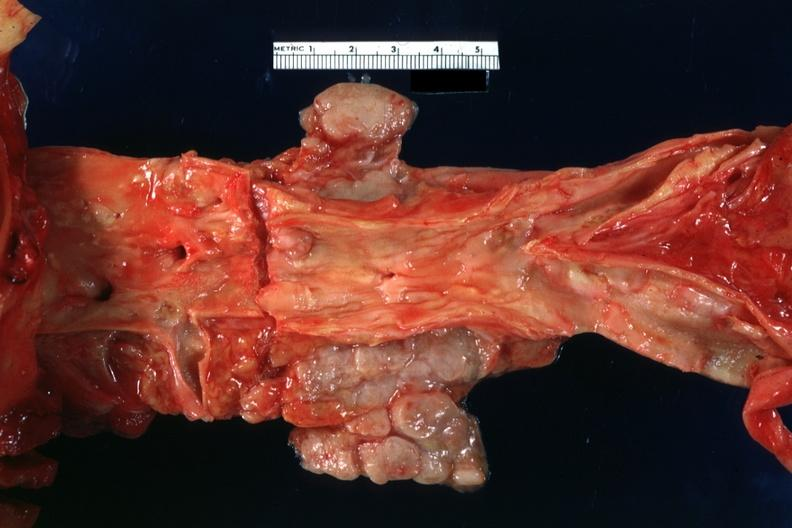what shows good atherosclerotic plaques?
Answer the question using a single word or phrase. Periaortic nodes with metastatic carcinoma aorta 